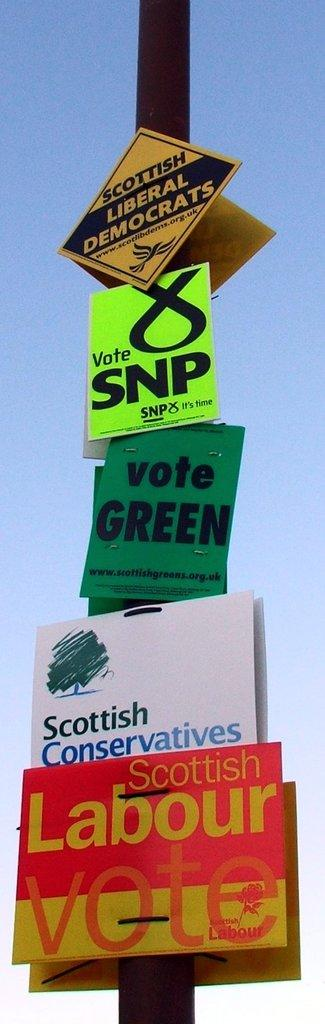<image>
Describe the image concisely. Political signs posted on a pole represent groups such as Scottish Liberal Democrats and Scottish Conservatives. 